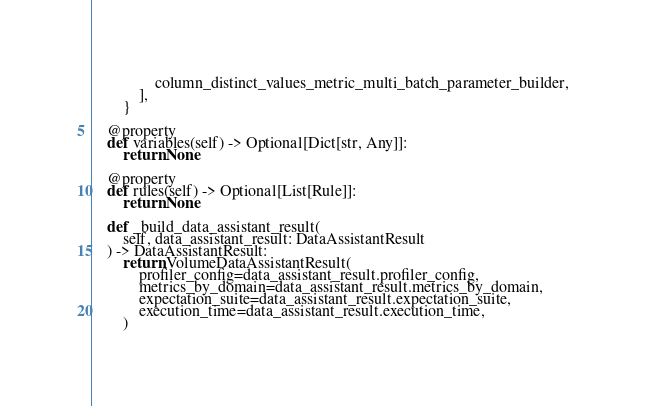<code> <loc_0><loc_0><loc_500><loc_500><_Python_>                column_distinct_values_metric_multi_batch_parameter_builder,
            ],
        }

    @property
    def variables(self) -> Optional[Dict[str, Any]]:
        return None

    @property
    def rules(self) -> Optional[List[Rule]]:
        return None

    def _build_data_assistant_result(
        self, data_assistant_result: DataAssistantResult
    ) -> DataAssistantResult:
        return VolumeDataAssistantResult(
            profiler_config=data_assistant_result.profiler_config,
            metrics_by_domain=data_assistant_result.metrics_by_domain,
            expectation_suite=data_assistant_result.expectation_suite,
            execution_time=data_assistant_result.execution_time,
        )
</code> 